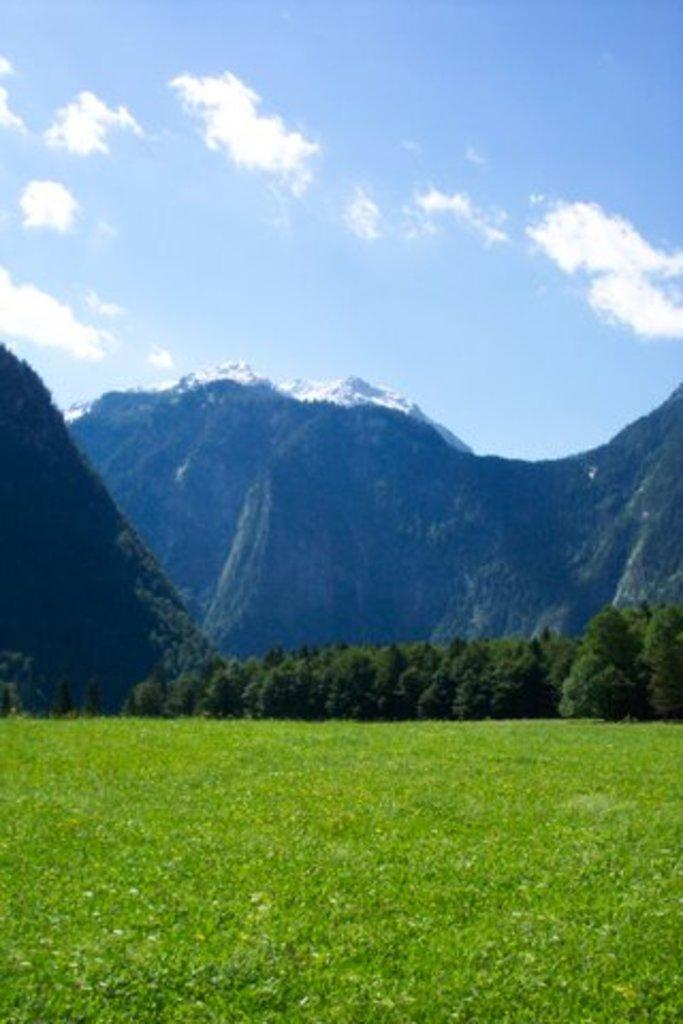What type of vegetation is present in the image? There are trees and grass in the image. What type of geographical feature can be seen in the image? There are mountains in the image. What is the condition of the mountains in the image? The mountains appear to be covered in snow. What is visible in the sky in the image? There are clouds in the sky. Who is the creator of the island in the image? There is no island present in the image, only mountains, trees, grass, and clouds. Can you see a balloon in the image? There is no balloon present in the image. 